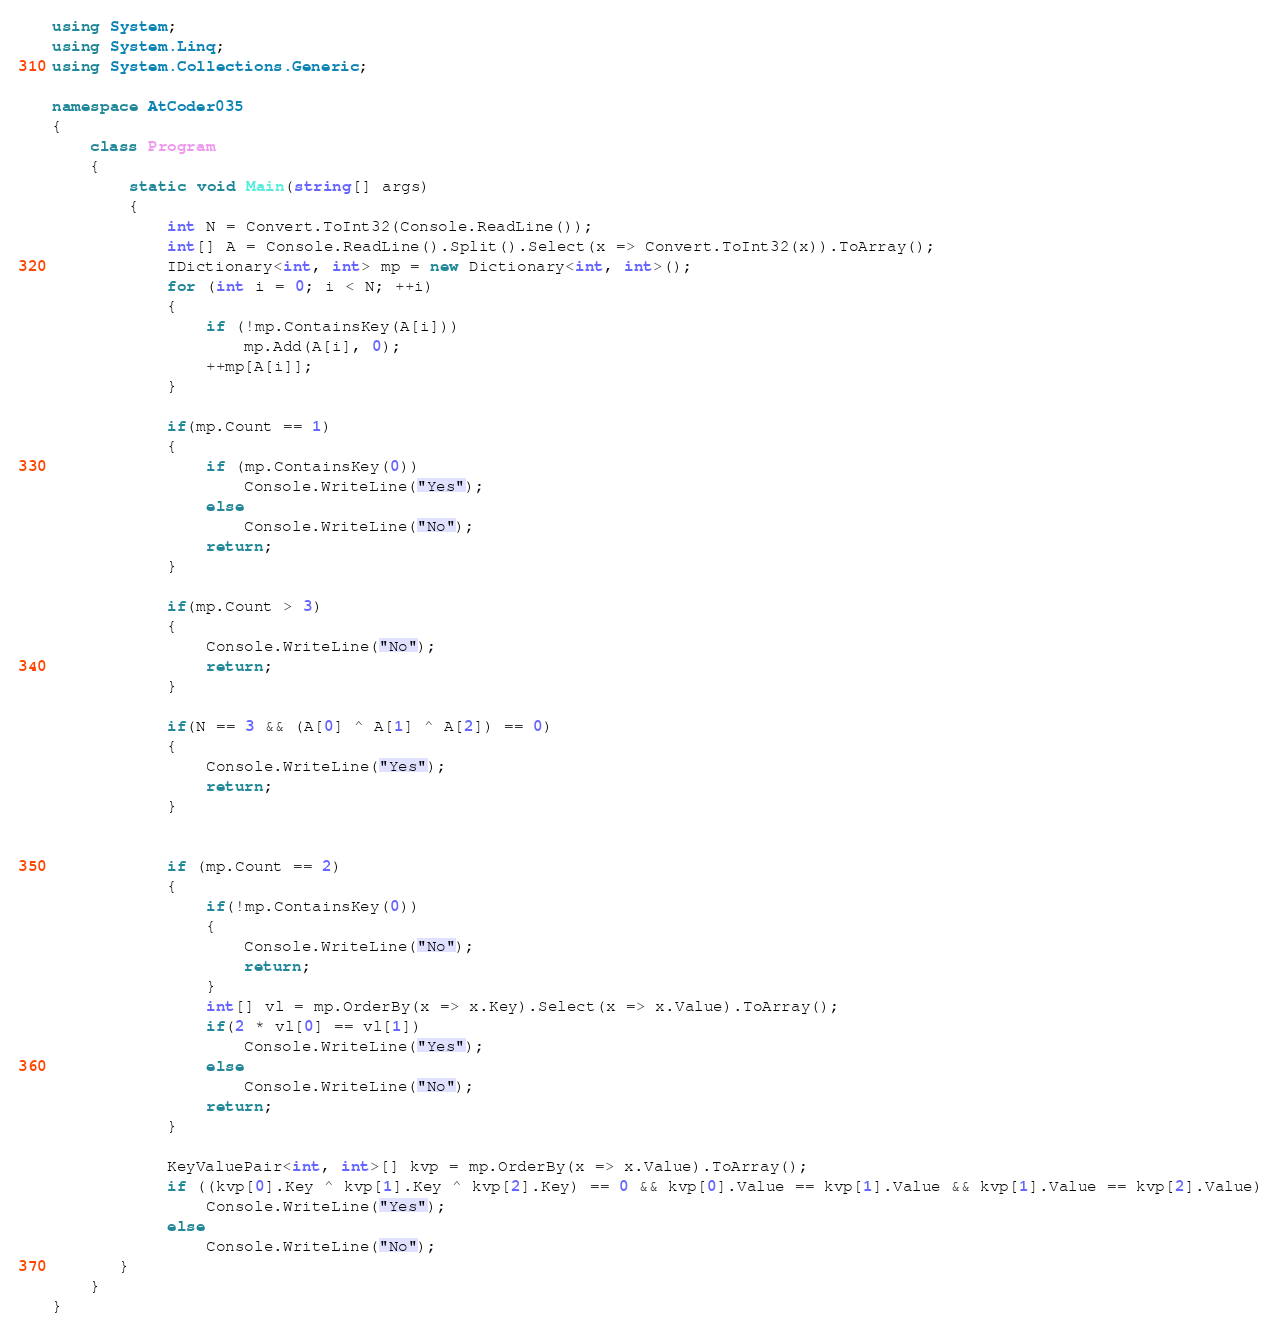Convert code to text. <code><loc_0><loc_0><loc_500><loc_500><_C#_>using System;
using System.Linq;
using System.Collections.Generic;

namespace AtCoder035
{
    class Program
    {
        static void Main(string[] args)
        {
            int N = Convert.ToInt32(Console.ReadLine());
            int[] A = Console.ReadLine().Split().Select(x => Convert.ToInt32(x)).ToArray();
            IDictionary<int, int> mp = new Dictionary<int, int>();
            for (int i = 0; i < N; ++i)
            {
                if (!mp.ContainsKey(A[i]))
                    mp.Add(A[i], 0);
                ++mp[A[i]];
            }

            if(mp.Count == 1)
            {
                if (mp.ContainsKey(0))
                    Console.WriteLine("Yes");
                else
                    Console.WriteLine("No");
                return;
            }

            if(mp.Count > 3)
            {
                Console.WriteLine("No");
                return;
            }

            if(N == 3 && (A[0] ^ A[1] ^ A[2]) == 0)
            {
                Console.WriteLine("Yes");
                return;
            }


            if (mp.Count == 2)
            {
                if(!mp.ContainsKey(0))
                {
                    Console.WriteLine("No");
                    return;
                }
                int[] vl = mp.OrderBy(x => x.Key).Select(x => x.Value).ToArray();
                if(2 * vl[0] == vl[1])
                    Console.WriteLine("Yes");
                else
                    Console.WriteLine("No");
                return;
            }

            KeyValuePair<int, int>[] kvp = mp.OrderBy(x => x.Value).ToArray();
            if ((kvp[0].Key ^ kvp[1].Key ^ kvp[2].Key) == 0 && kvp[0].Value == kvp[1].Value && kvp[1].Value == kvp[2].Value)
                Console.WriteLine("Yes");
            else
                Console.WriteLine("No");
       }
    }
}</code> 